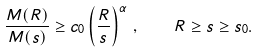Convert formula to latex. <formula><loc_0><loc_0><loc_500><loc_500>\frac { M ( R ) } { M ( s ) } \geq c _ { 0 } \left ( \frac { R } { s } \right ) ^ { \alpha } \, , \quad R \geq s \geq s _ { 0 } .</formula> 